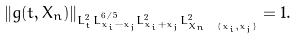<formula> <loc_0><loc_0><loc_500><loc_500>\| g ( t , X _ { n } ) \| _ { L _ { t } ^ { 2 } L _ { x _ { i } - x _ { j } } ^ { 6 / 5 } L _ { x _ { i } + x _ { j } } ^ { 2 } L _ { X _ { n } \ \{ x _ { i } , x _ { j } \} } ^ { 2 } } = 1 .</formula> 